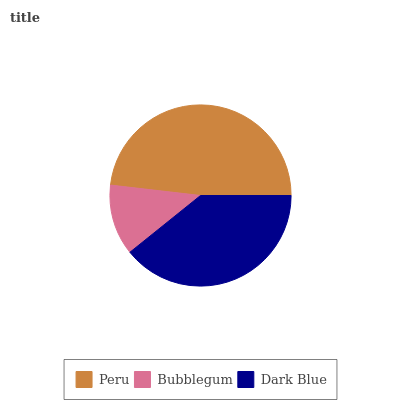Is Bubblegum the minimum?
Answer yes or no. Yes. Is Peru the maximum?
Answer yes or no. Yes. Is Dark Blue the minimum?
Answer yes or no. No. Is Dark Blue the maximum?
Answer yes or no. No. Is Dark Blue greater than Bubblegum?
Answer yes or no. Yes. Is Bubblegum less than Dark Blue?
Answer yes or no. Yes. Is Bubblegum greater than Dark Blue?
Answer yes or no. No. Is Dark Blue less than Bubblegum?
Answer yes or no. No. Is Dark Blue the high median?
Answer yes or no. Yes. Is Dark Blue the low median?
Answer yes or no. Yes. Is Bubblegum the high median?
Answer yes or no. No. Is Bubblegum the low median?
Answer yes or no. No. 